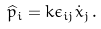<formula> <loc_0><loc_0><loc_500><loc_500>\widehat { p } _ { i } = k \epsilon _ { i j } \dot { x } _ { j } \, .</formula> 